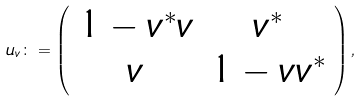<formula> <loc_0><loc_0><loc_500><loc_500>u _ { v } \colon = \left ( \begin{array} { c c } 1 - v ^ { * } v & v ^ { * } \\ v & 1 - v v ^ { * } \\ \end{array} \right ) ,</formula> 